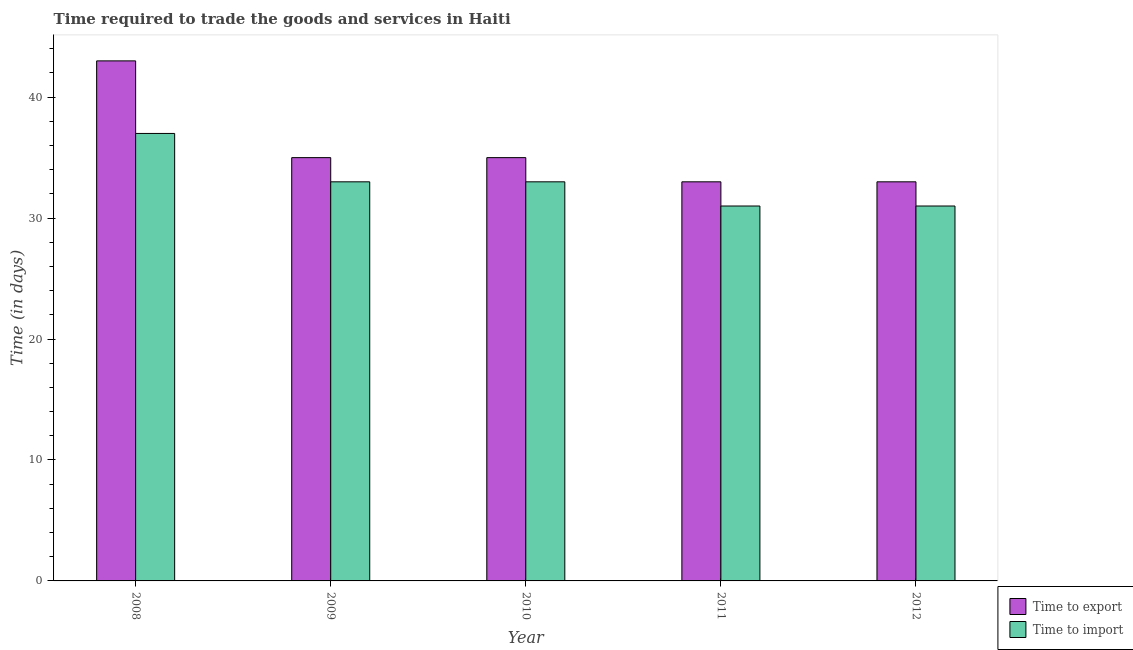How many different coloured bars are there?
Offer a very short reply. 2. Are the number of bars on each tick of the X-axis equal?
Your answer should be very brief. Yes. How many bars are there on the 2nd tick from the right?
Provide a short and direct response. 2. In how many cases, is the number of bars for a given year not equal to the number of legend labels?
Provide a succinct answer. 0. What is the time to import in 2010?
Offer a very short reply. 33. Across all years, what is the maximum time to export?
Offer a very short reply. 43. Across all years, what is the minimum time to export?
Offer a very short reply. 33. What is the total time to export in the graph?
Ensure brevity in your answer.  179. What is the difference between the time to export in 2010 and that in 2011?
Provide a succinct answer. 2. What is the difference between the time to import in 2008 and the time to export in 2010?
Provide a succinct answer. 4. What is the average time to export per year?
Your answer should be very brief. 35.8. In how many years, is the time to export greater than 34 days?
Make the answer very short. 3. What is the ratio of the time to export in 2008 to that in 2010?
Your response must be concise. 1.23. What is the difference between the highest and the second highest time to export?
Ensure brevity in your answer.  8. What is the difference between the highest and the lowest time to export?
Provide a succinct answer. 10. Is the sum of the time to import in 2008 and 2009 greater than the maximum time to export across all years?
Provide a short and direct response. Yes. What does the 2nd bar from the left in 2011 represents?
Your answer should be compact. Time to import. What does the 2nd bar from the right in 2008 represents?
Make the answer very short. Time to export. Are all the bars in the graph horizontal?
Your answer should be compact. No. Are the values on the major ticks of Y-axis written in scientific E-notation?
Offer a terse response. No. Does the graph contain grids?
Ensure brevity in your answer.  No. Where does the legend appear in the graph?
Keep it short and to the point. Bottom right. How are the legend labels stacked?
Your answer should be compact. Vertical. What is the title of the graph?
Your answer should be compact. Time required to trade the goods and services in Haiti. What is the label or title of the X-axis?
Your response must be concise. Year. What is the label or title of the Y-axis?
Ensure brevity in your answer.  Time (in days). What is the Time (in days) of Time to export in 2008?
Ensure brevity in your answer.  43. What is the Time (in days) in Time to import in 2009?
Provide a short and direct response. 33. What is the Time (in days) in Time to import in 2010?
Make the answer very short. 33. What is the Time (in days) of Time to export in 2011?
Give a very brief answer. 33. What is the Time (in days) of Time to import in 2011?
Make the answer very short. 31. What is the Time (in days) of Time to export in 2012?
Ensure brevity in your answer.  33. What is the Time (in days) of Time to import in 2012?
Offer a terse response. 31. Across all years, what is the maximum Time (in days) of Time to export?
Your response must be concise. 43. Across all years, what is the minimum Time (in days) of Time to export?
Offer a terse response. 33. Across all years, what is the minimum Time (in days) of Time to import?
Offer a terse response. 31. What is the total Time (in days) in Time to export in the graph?
Your answer should be compact. 179. What is the total Time (in days) of Time to import in the graph?
Your answer should be very brief. 165. What is the difference between the Time (in days) of Time to export in 2008 and that in 2009?
Offer a terse response. 8. What is the difference between the Time (in days) in Time to export in 2008 and that in 2010?
Your response must be concise. 8. What is the difference between the Time (in days) of Time to import in 2008 and that in 2012?
Provide a short and direct response. 6. What is the difference between the Time (in days) of Time to import in 2009 and that in 2010?
Make the answer very short. 0. What is the difference between the Time (in days) of Time to export in 2009 and that in 2011?
Ensure brevity in your answer.  2. What is the difference between the Time (in days) in Time to export in 2009 and that in 2012?
Ensure brevity in your answer.  2. What is the difference between the Time (in days) in Time to import in 2009 and that in 2012?
Your answer should be compact. 2. What is the difference between the Time (in days) in Time to import in 2010 and that in 2012?
Ensure brevity in your answer.  2. What is the difference between the Time (in days) of Time to export in 2008 and the Time (in days) of Time to import in 2009?
Provide a succinct answer. 10. What is the difference between the Time (in days) in Time to export in 2008 and the Time (in days) in Time to import in 2010?
Ensure brevity in your answer.  10. What is the difference between the Time (in days) in Time to export in 2008 and the Time (in days) in Time to import in 2011?
Keep it short and to the point. 12. What is the difference between the Time (in days) in Time to export in 2008 and the Time (in days) in Time to import in 2012?
Make the answer very short. 12. What is the difference between the Time (in days) in Time to export in 2009 and the Time (in days) in Time to import in 2010?
Your answer should be compact. 2. What is the difference between the Time (in days) in Time to export in 2010 and the Time (in days) in Time to import in 2011?
Your answer should be very brief. 4. What is the difference between the Time (in days) of Time to export in 2011 and the Time (in days) of Time to import in 2012?
Ensure brevity in your answer.  2. What is the average Time (in days) of Time to export per year?
Provide a short and direct response. 35.8. In the year 2009, what is the difference between the Time (in days) of Time to export and Time (in days) of Time to import?
Your response must be concise. 2. In the year 2010, what is the difference between the Time (in days) of Time to export and Time (in days) of Time to import?
Make the answer very short. 2. In the year 2012, what is the difference between the Time (in days) in Time to export and Time (in days) in Time to import?
Your answer should be compact. 2. What is the ratio of the Time (in days) of Time to export in 2008 to that in 2009?
Give a very brief answer. 1.23. What is the ratio of the Time (in days) in Time to import in 2008 to that in 2009?
Your answer should be compact. 1.12. What is the ratio of the Time (in days) of Time to export in 2008 to that in 2010?
Your answer should be compact. 1.23. What is the ratio of the Time (in days) of Time to import in 2008 to that in 2010?
Make the answer very short. 1.12. What is the ratio of the Time (in days) in Time to export in 2008 to that in 2011?
Offer a terse response. 1.3. What is the ratio of the Time (in days) of Time to import in 2008 to that in 2011?
Your answer should be compact. 1.19. What is the ratio of the Time (in days) of Time to export in 2008 to that in 2012?
Your answer should be compact. 1.3. What is the ratio of the Time (in days) in Time to import in 2008 to that in 2012?
Provide a succinct answer. 1.19. What is the ratio of the Time (in days) in Time to export in 2009 to that in 2010?
Give a very brief answer. 1. What is the ratio of the Time (in days) of Time to export in 2009 to that in 2011?
Your answer should be compact. 1.06. What is the ratio of the Time (in days) in Time to import in 2009 to that in 2011?
Your response must be concise. 1.06. What is the ratio of the Time (in days) of Time to export in 2009 to that in 2012?
Provide a succinct answer. 1.06. What is the ratio of the Time (in days) of Time to import in 2009 to that in 2012?
Give a very brief answer. 1.06. What is the ratio of the Time (in days) in Time to export in 2010 to that in 2011?
Give a very brief answer. 1.06. What is the ratio of the Time (in days) of Time to import in 2010 to that in 2011?
Your answer should be compact. 1.06. What is the ratio of the Time (in days) of Time to export in 2010 to that in 2012?
Provide a succinct answer. 1.06. What is the ratio of the Time (in days) in Time to import in 2010 to that in 2012?
Your answer should be very brief. 1.06. What is the ratio of the Time (in days) of Time to export in 2011 to that in 2012?
Keep it short and to the point. 1. 